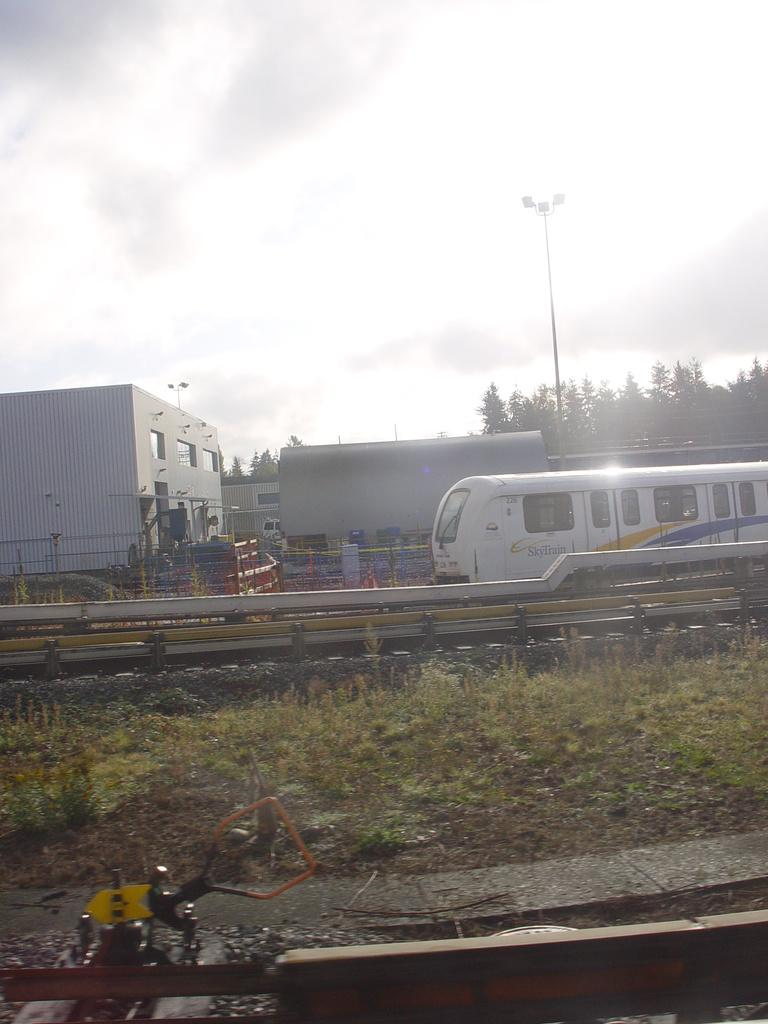What type of vegetation is present in the image? There is grass in the image. What type of transportation infrastructure can be seen in the image? There is a railway track in the image. What is traveling along the railway track? There is a train in the image. What type of structures are visible in the image? There are buildings in the image. What other natural elements can be seen in the image? There are trees in the image. What type of lighting is present in the image? There are street lamps in the image. What is visible at the top of the image? The sky is visible at the top of the image. What type of skin condition is visible on the train in the image? There is no skin condition present in the image, as the train is an inanimate object and does not have skin. How does the jam travel along the railway track in the image? There is no jam present in the image, so it cannot travel along the railway track. 